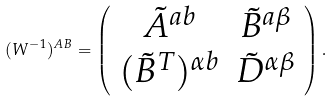Convert formula to latex. <formula><loc_0><loc_0><loc_500><loc_500>( W ^ { - 1 } ) ^ { A B } = \left ( \begin{array} { c c } \tilde { A } ^ { a b } & \tilde { B } ^ { a \beta } \\ ( \tilde { B } ^ { T } ) ^ { \alpha b } & \tilde { D } ^ { \alpha \beta } \end{array} \right ) .</formula> 